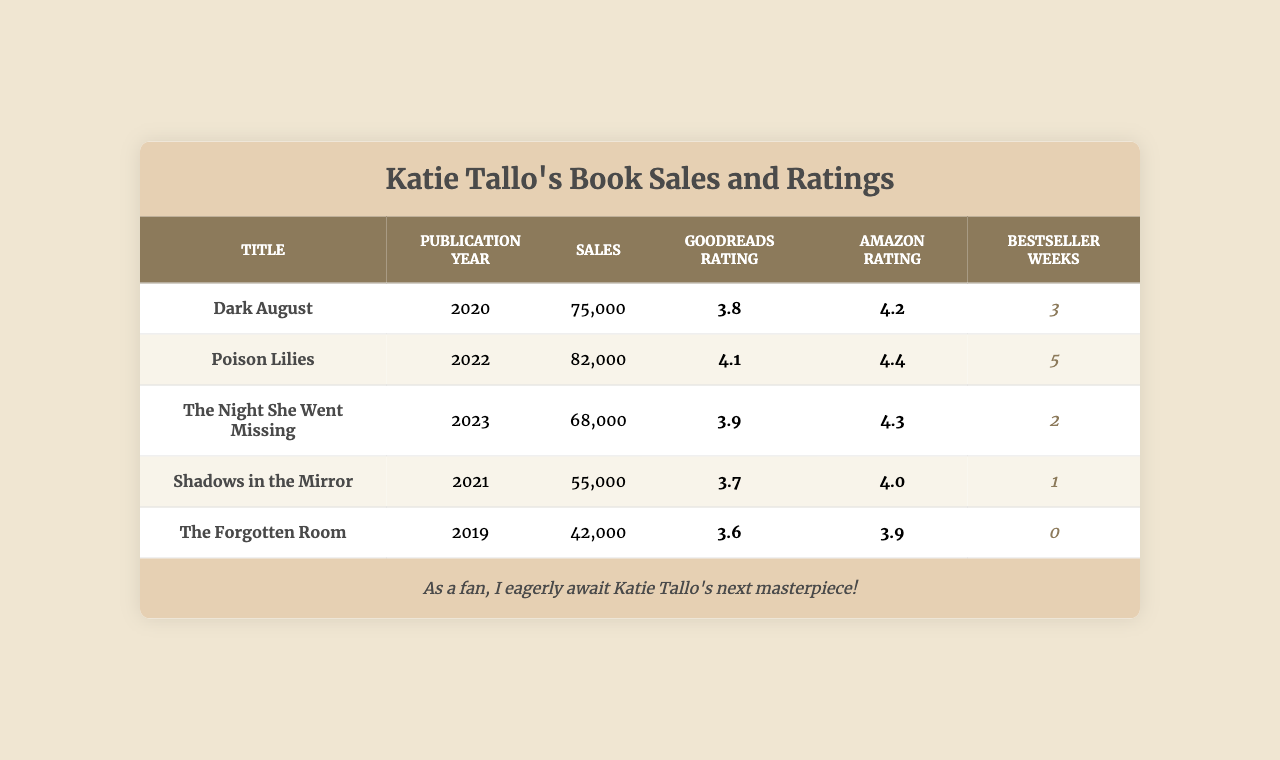What is the title of Katie Tallo's book with the highest sales? According to the table, "Poison Lilies" has the highest sales figure at 82,000.
Answer: Poison Lilies Which book was published in 2021? In the table, "Shadows in the Mirror" is listed under the publication year of 2021.
Answer: Shadows in the Mirror What is the average Goodreads rating of Katie Tallo's books? To find the average, sum up all Goodreads ratings (3.8 + 4.1 + 3.9 + 3.7 + 3.6 = 19.1) and divide by the number of books (5). The average is 19.1 / 5 = 3.82.
Answer: 3.8 Did "The Forgotten Room" spend any weeks on the bestseller list? The data shows that "The Forgotten Room" has 0 weeks on the bestseller list, which means it did not spend any weeks there.
Answer: No Which book has the highest Amazon rating, and what is that rating? From the table, "Poison Lilies" has the highest Amazon rating of 4.4.
Answer: Poison Lilies, 4.4 What is the difference in sales between "Dark August" and "Shadows in the Mirror"? "Dark August" sold 75,000 copies, while "Shadows in the Mirror" sold 55,000. The difference is 75,000 - 55,000 = 20,000.
Answer: 20,000 Which book has both the lowest Goodreads rating and the least sales? "The Forgotten Room" has the lowest Goodreads rating of 3.6 and the least sales at 42,000; it meets both criteria.
Answer: The Forgotten Room How many total weeks did Katie Tallo's books spend on the bestseller list? Adding the weeks on the bestseller list: 3 + 5 + 2 + 1 + 0 = 11 weeks total.
Answer: 11 weeks What is the Amazon rating of "The Night She Went Missing"? The table specifies that "The Night She Went Missing" has an Amazon rating of 4.3.
Answer: 4.3 Which book published last has the most sales? "The Night She Went Missing," published in 2023, has 68,000 sales, which is more than any other book published after that year.
Answer: The Night She Went Missing 